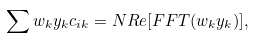Convert formula to latex. <formula><loc_0><loc_0><loc_500><loc_500>\sum w _ { k } y _ { k } c _ { i k } = N R e [ F F T ( w _ { k } y _ { k } ) ] ,</formula> 